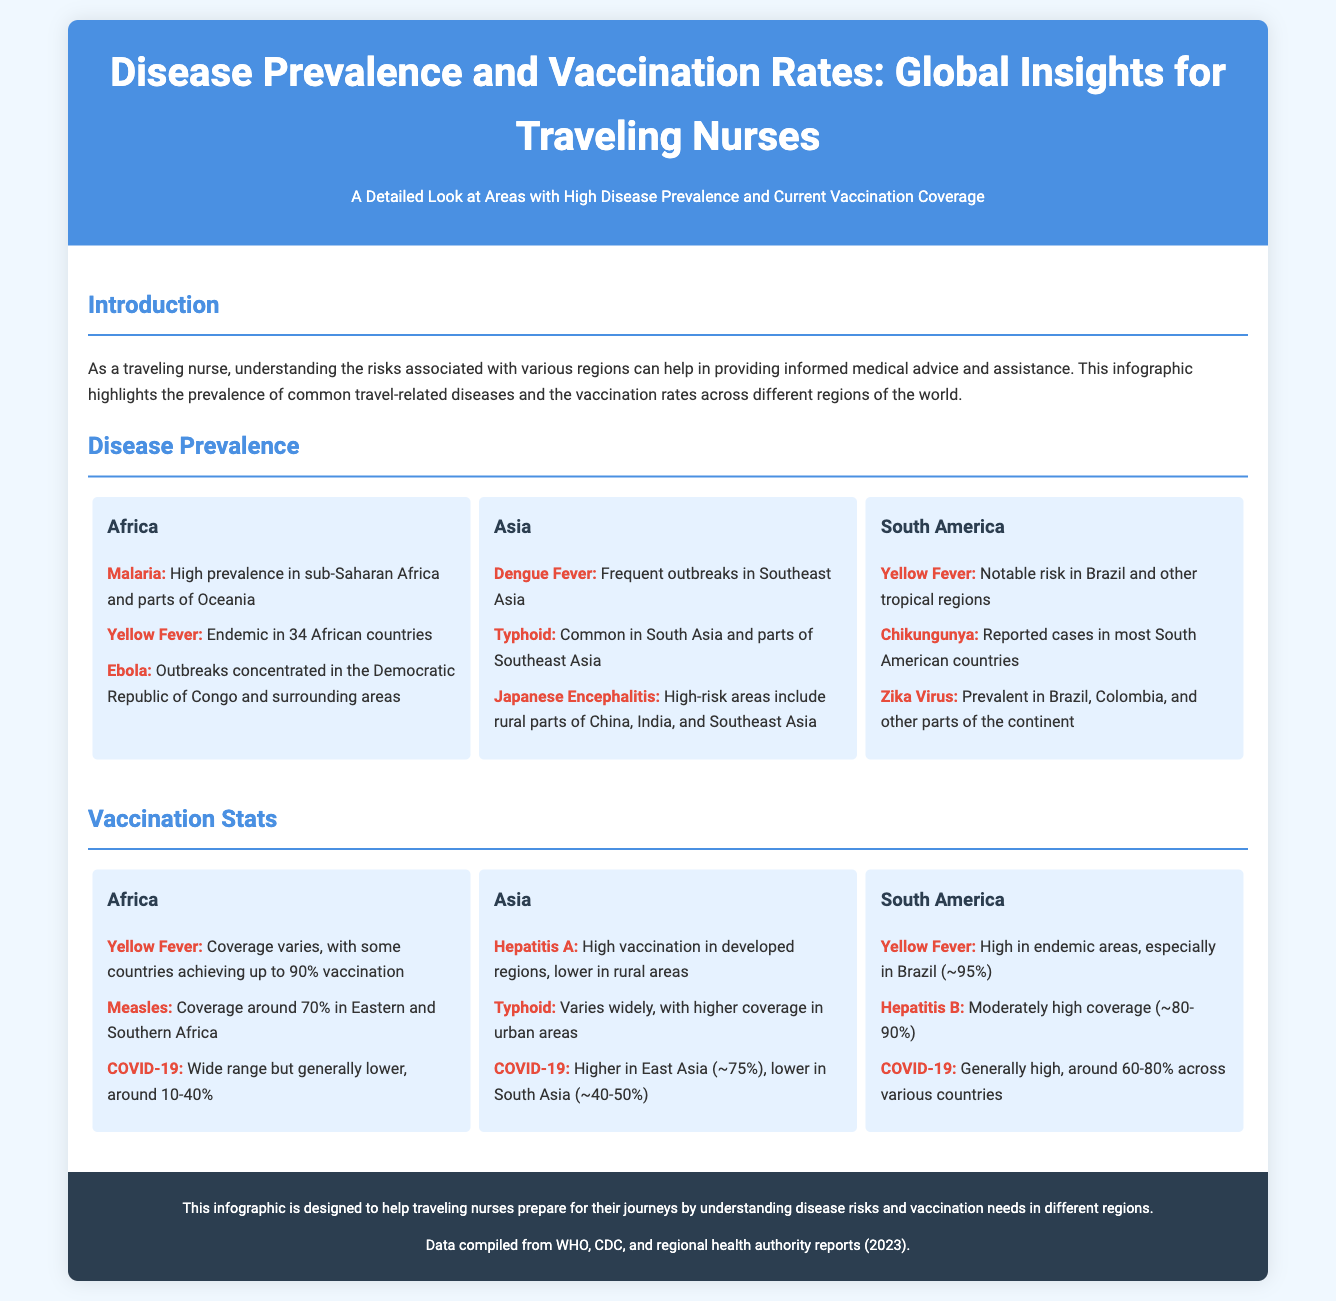What disease shows high prevalence in sub-Saharan Africa? The document states that malaria has high prevalence in sub-Saharan Africa.
Answer: Malaria What is the COVID-19 vaccination coverage range in Africa? According to the document, COVID-19 vaccination coverage in Africa ranges from around 10-40%.
Answer: 10-40% Which disease has a notable risk in Brazil? The document indicates that yellow fever has a notable risk in Brazil.
Answer: Yellow Fever What is the vaccination coverage for yellow fever in endemic areas of South America? The document mentions that yellow fever vaccination coverage in endemic areas, especially in Brazil, is approximately 95%.
Answer: ~95% What disease is frequently reported in Southeast Asia? The document identifies dengue fever as frequently reported in Southeast Asia.
Answer: Dengue Fever Which region shows high incidence of Japanese encephalitis? The document specifies that high-risk areas for Japanese encephalitis include rural parts of China, India, and Southeast Asia.
Answer: Asia What is the vaccination coverage for hepatitis A in developed regions of Asia? The document notes that hepatitis A has high vaccination rates in developed regions of Asia.
Answer: High Which disease has varying vaccination coverage, higher in urban areas in Asia? The document states that typhoid varies widely but has higher coverage in urban areas.
Answer: Typhoid 